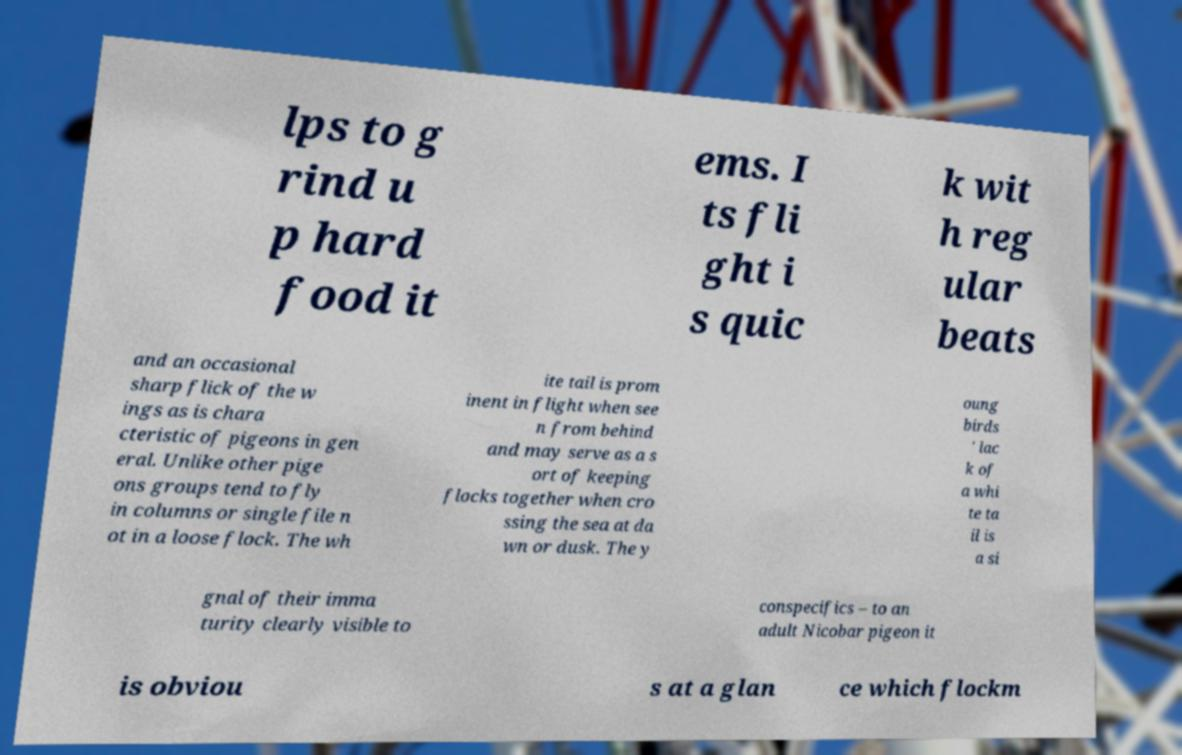Could you assist in decoding the text presented in this image and type it out clearly? lps to g rind u p hard food it ems. I ts fli ght i s quic k wit h reg ular beats and an occasional sharp flick of the w ings as is chara cteristic of pigeons in gen eral. Unlike other pige ons groups tend to fly in columns or single file n ot in a loose flock. The wh ite tail is prom inent in flight when see n from behind and may serve as a s ort of keeping flocks together when cro ssing the sea at da wn or dusk. The y oung birds ' lac k of a whi te ta il is a si gnal of their imma turity clearly visible to conspecifics – to an adult Nicobar pigeon it is obviou s at a glan ce which flockm 